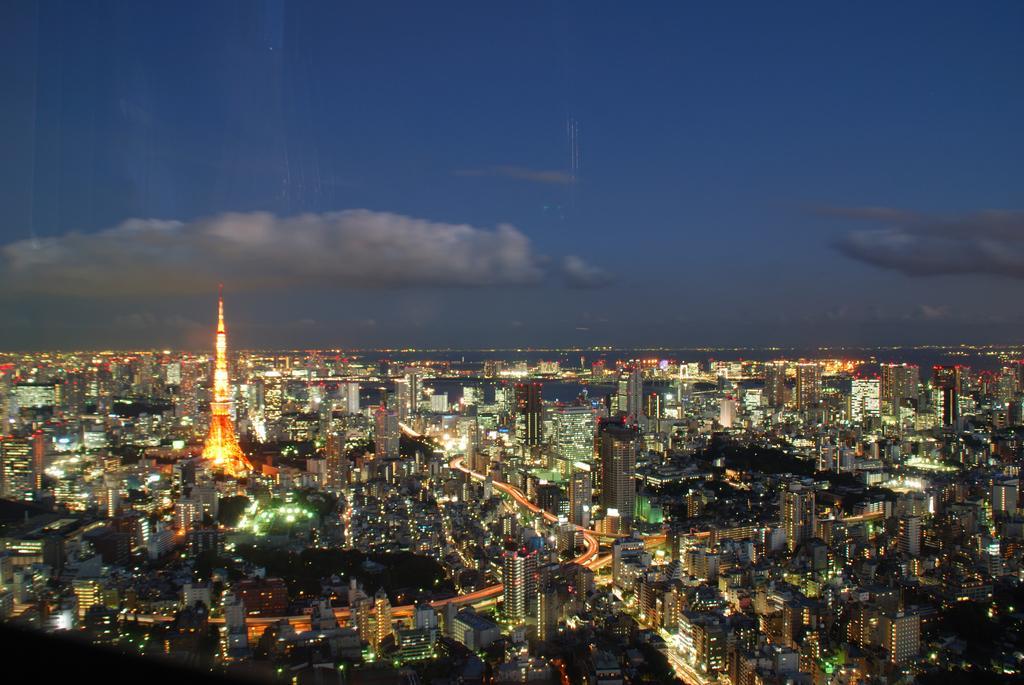Can you describe this image briefly? This image is taken outdoors. At the top of the image there is a sky with clouds. At the bottom of the image there are a few roads and a few vehicles are moving on the road. There are many buildings, towers, skyscrapers and house with walls, windows,roofs, railings, doors and balconies and there are many lamps. 